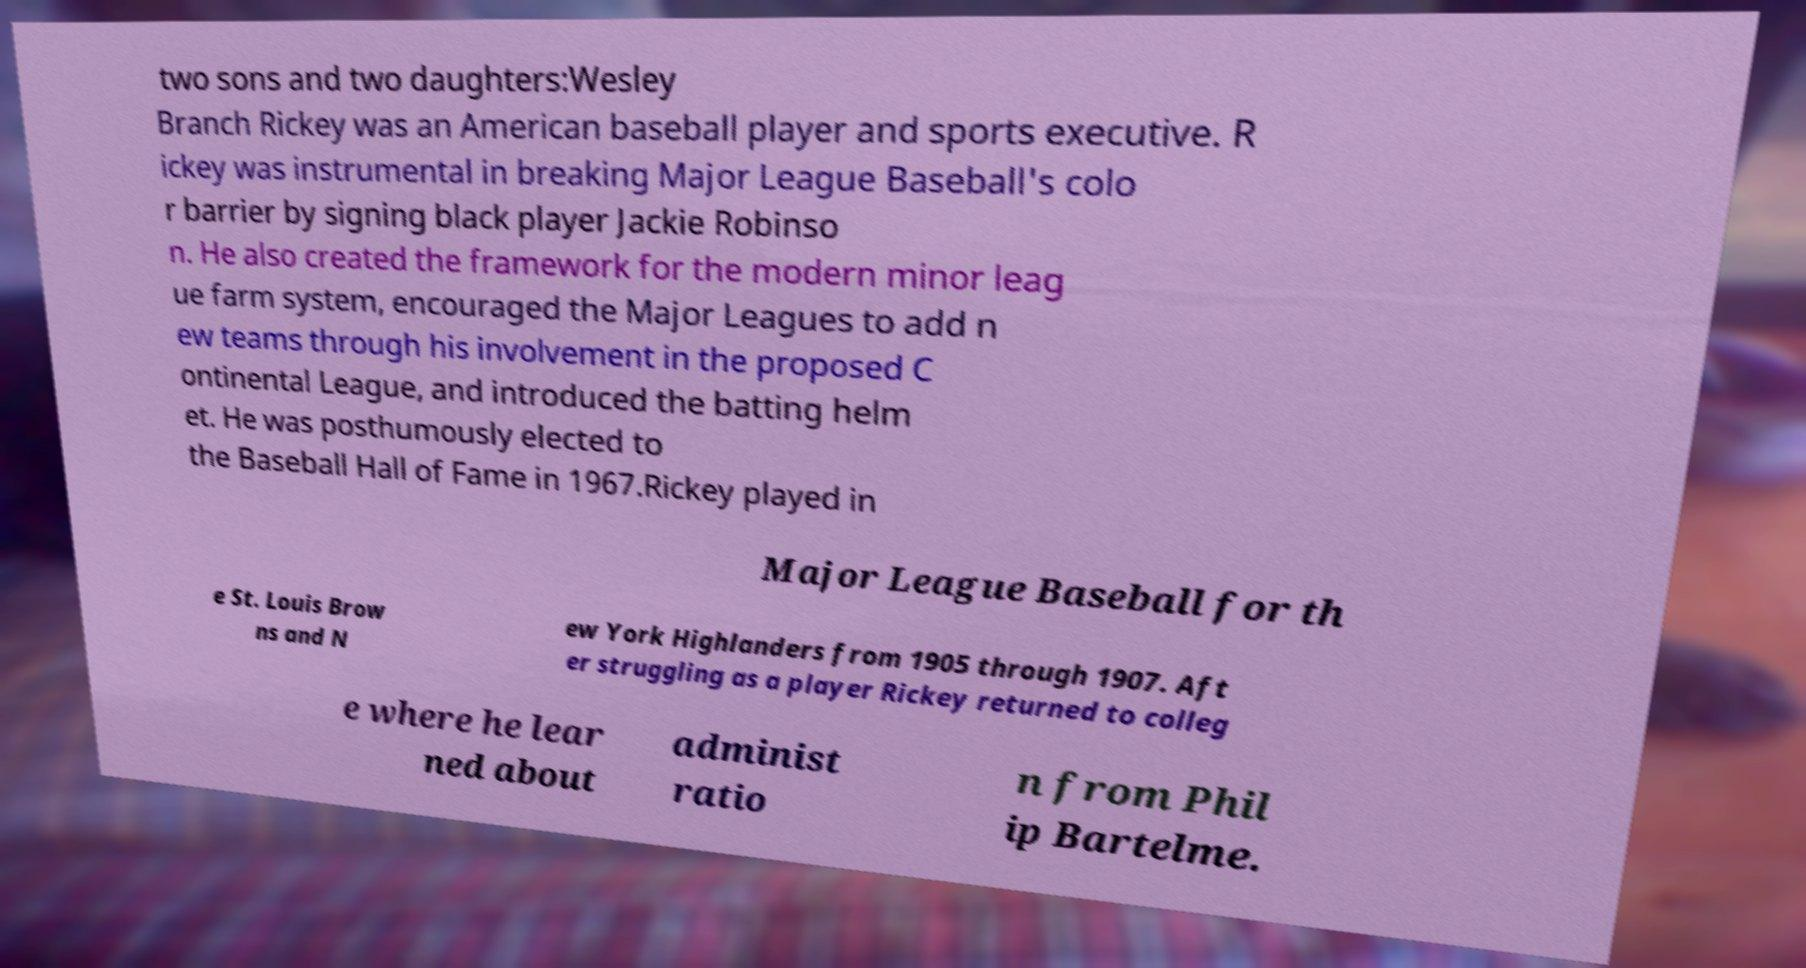Can you accurately transcribe the text from the provided image for me? two sons and two daughters:Wesley Branch Rickey was an American baseball player and sports executive. R ickey was instrumental in breaking Major League Baseball's colo r barrier by signing black player Jackie Robinso n. He also created the framework for the modern minor leag ue farm system, encouraged the Major Leagues to add n ew teams through his involvement in the proposed C ontinental League, and introduced the batting helm et. He was posthumously elected to the Baseball Hall of Fame in 1967.Rickey played in Major League Baseball for th e St. Louis Brow ns and N ew York Highlanders from 1905 through 1907. Aft er struggling as a player Rickey returned to colleg e where he lear ned about administ ratio n from Phil ip Bartelme. 